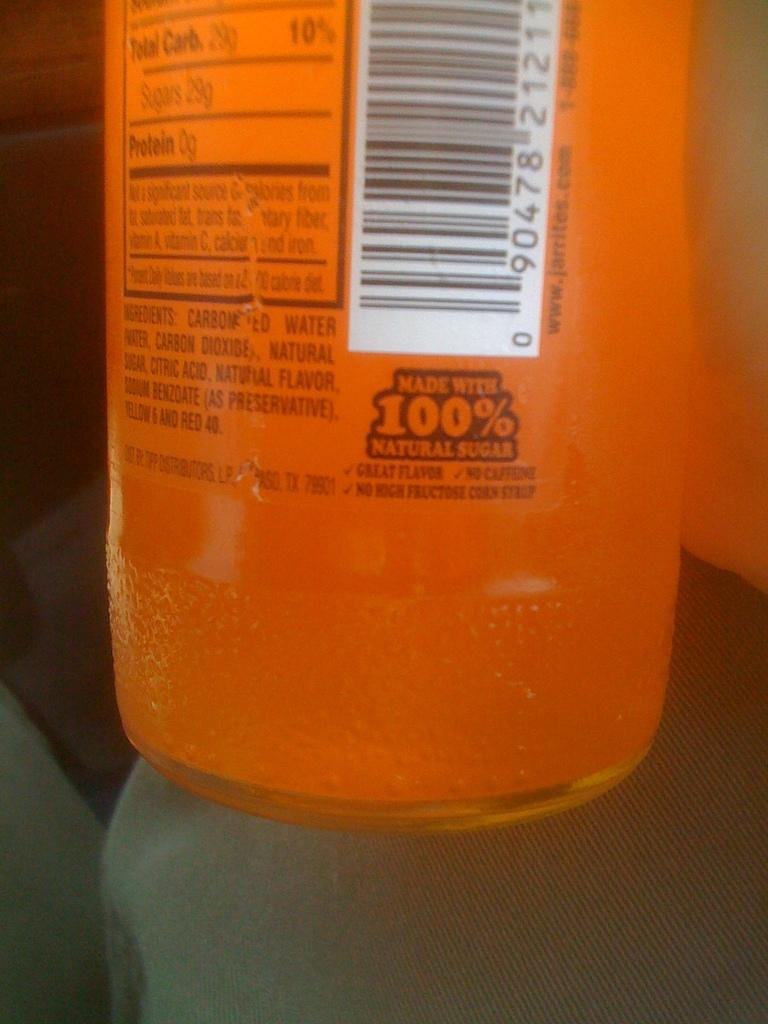<image>
Describe the image concisely. Orange bottle which says Made with 100% natural sugar. 